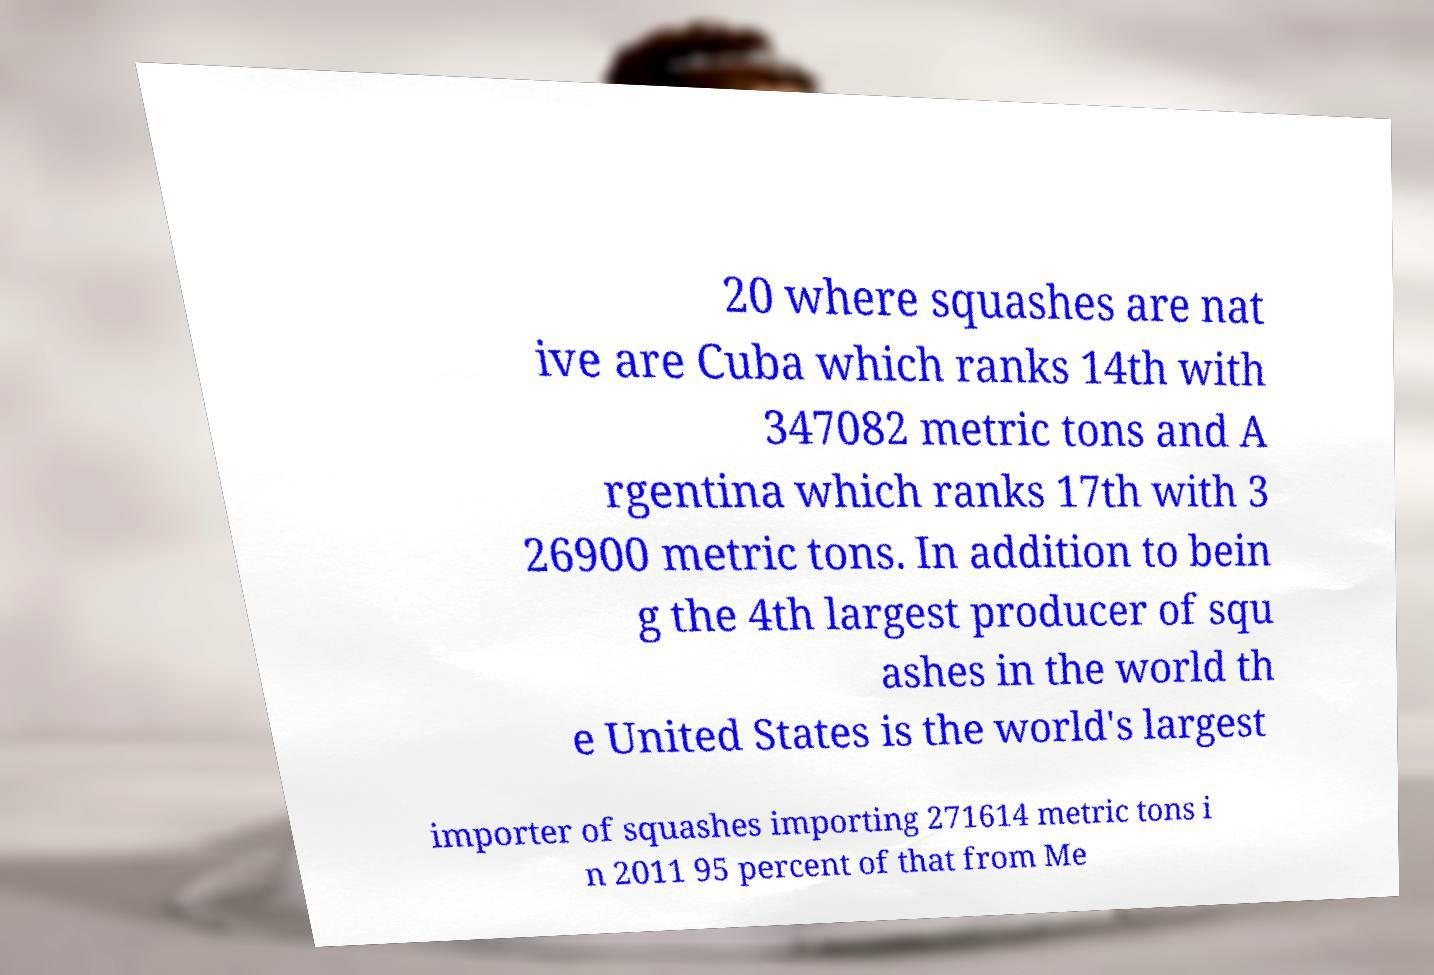Could you extract and type out the text from this image? 20 where squashes are nat ive are Cuba which ranks 14th with 347082 metric tons and A rgentina which ranks 17th with 3 26900 metric tons. In addition to bein g the 4th largest producer of squ ashes in the world th e United States is the world's largest importer of squashes importing 271614 metric tons i n 2011 95 percent of that from Me 